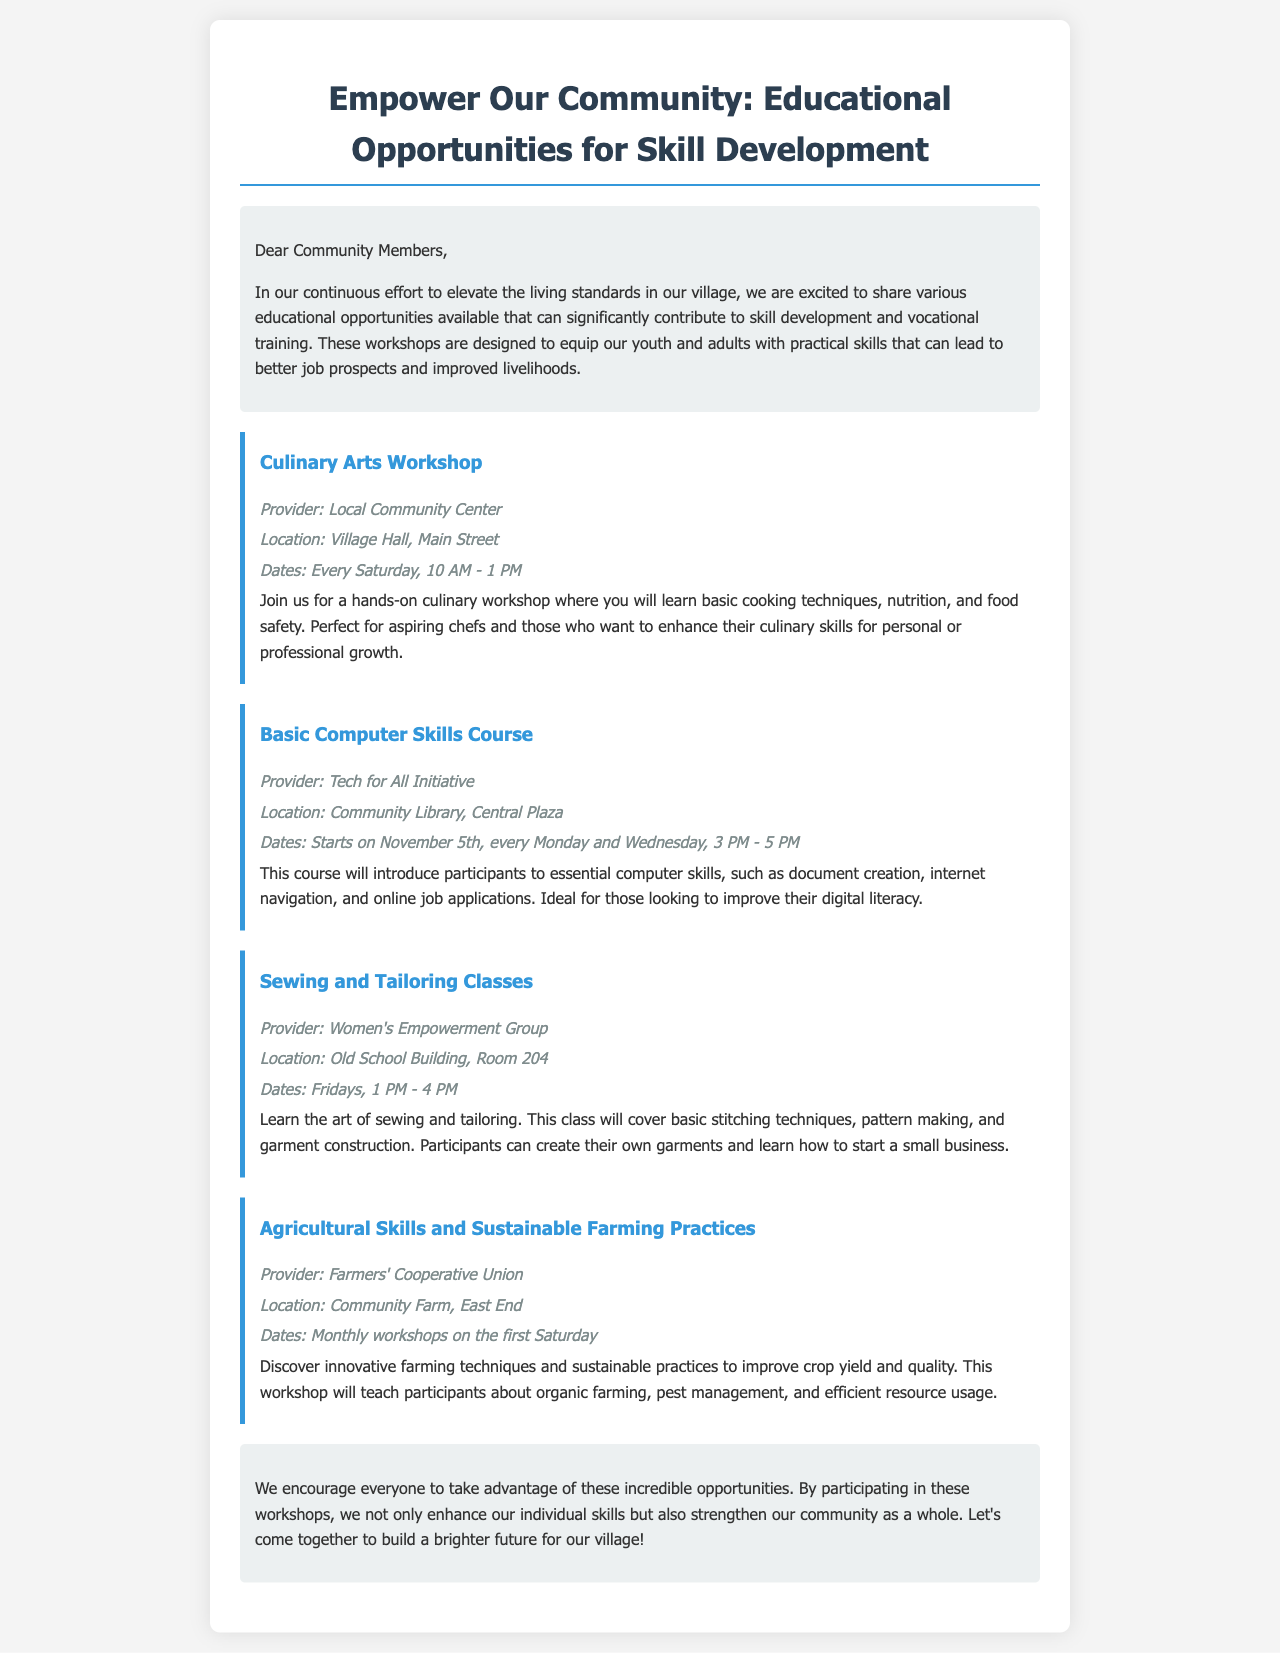What is the title of the newsletter? The title is stated at the top of the document, summarizing the purpose of the content.
Answer: Empower Our Community: Educational Opportunities for Skill Development What day of the week does the Culinary Arts Workshop take place? The document specifies the day of the week for this workshop in the details section.
Answer: Saturday Who provides the Basic Computer Skills Course? The provider of the course is mentioned in the details of the respective workshop.
Answer: Tech for All Initiative When does the Sewing and Tailoring Classes workshop occur? The schedule for these classes is provided within the description of the workshop.
Answer: Fridays, 1 PM - 4 PM What is the main focus of the Agricultural Skills and Sustainable Farming Practices workshop? The main focus is indicated in the description of what participants will learn in this workshop.
Answer: Innovative farming techniques and sustainable practices Which workshop takes place at the Old School Building? This information can be found in the details of the respective workshop section.
Answer: Sewing and Tailoring Classes What is the duration of the Culinary Arts Workshop? The length of the workshop is stated in the time section of its details.
Answer: 3 hours How often are the Agricultural Skills workshops held? The frequency of the workshops is explained in the details pertaining to this particular workshop.
Answer: Monthly 